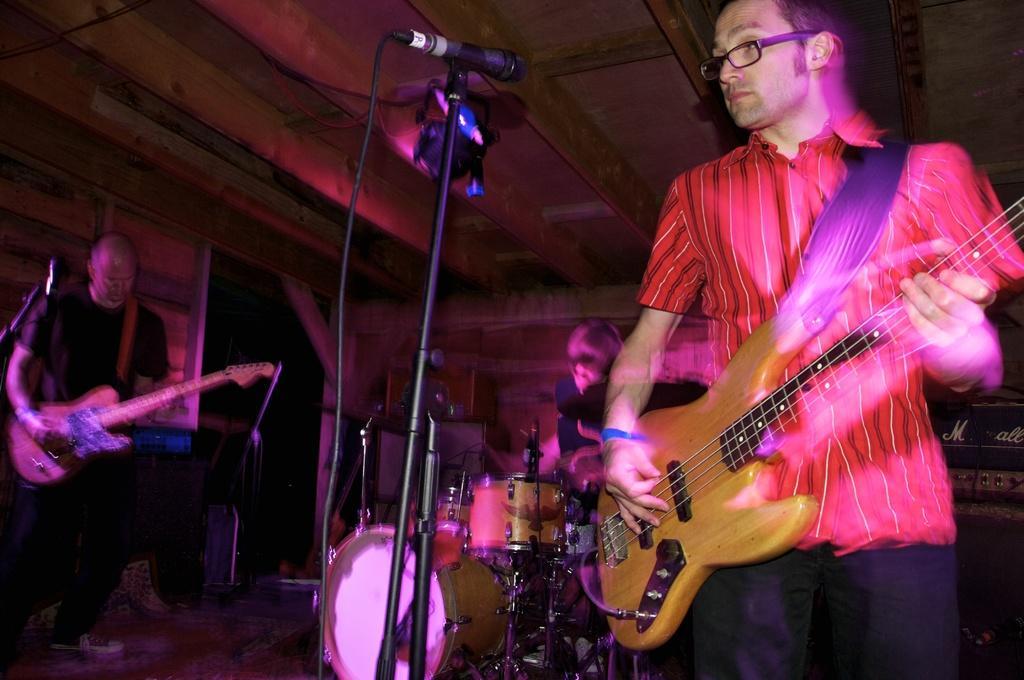How would you summarize this image in a sentence or two? In this image there is a man standing and playing a guitar, another man sitting and playing a guitar,another man sitting and playing a drums and at the back ground there is a door. 